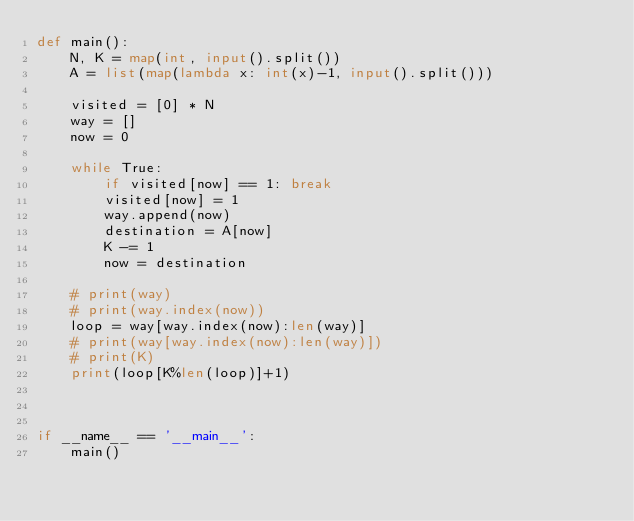<code> <loc_0><loc_0><loc_500><loc_500><_Python_>def main():
    N, K = map(int, input().split())
    A = list(map(lambda x: int(x)-1, input().split()))

    visited = [0] * N
    way = []
    now = 0

    while True:
        if visited[now] == 1: break
        visited[now] = 1
        way.append(now)
        destination = A[now]
        K -= 1
        now = destination

    # print(way)
    # print(way.index(now))
    loop = way[way.index(now):len(way)]
    # print(way[way.index(now):len(way)])
    # print(K)
    print(loop[K%len(loop)]+1)



if __name__ == '__main__':
    main()
</code> 